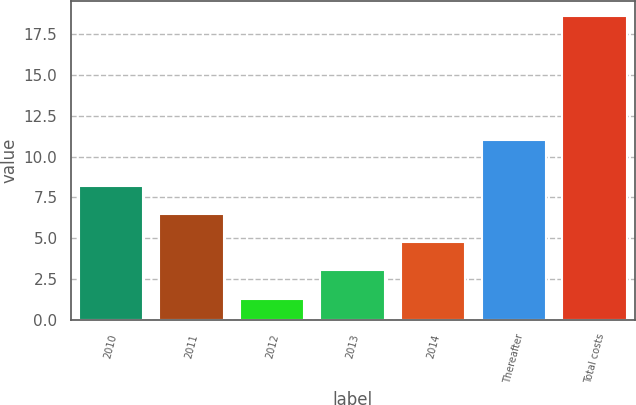Convert chart to OTSL. <chart><loc_0><loc_0><loc_500><loc_500><bar_chart><fcel>2010<fcel>2011<fcel>2012<fcel>2013<fcel>2014<fcel>Thereafter<fcel>Total costs<nl><fcel>8.22<fcel>6.49<fcel>1.3<fcel>3.03<fcel>4.76<fcel>11<fcel>18.6<nl></chart> 